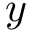<formula> <loc_0><loc_0><loc_500><loc_500>y</formula> 